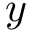<formula> <loc_0><loc_0><loc_500><loc_500>y</formula> 